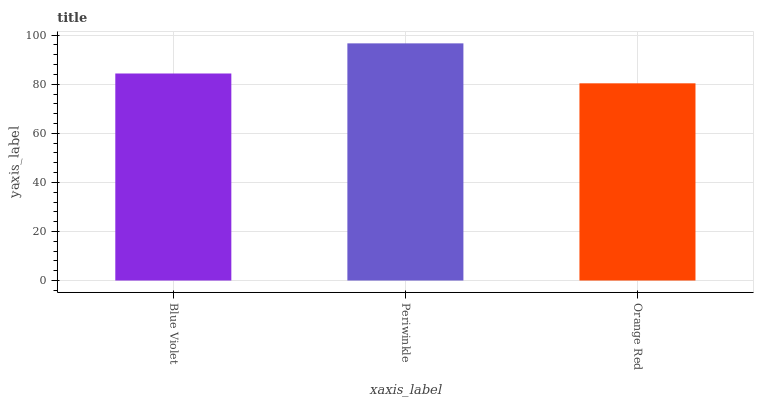Is Orange Red the minimum?
Answer yes or no. Yes. Is Periwinkle the maximum?
Answer yes or no. Yes. Is Periwinkle the minimum?
Answer yes or no. No. Is Orange Red the maximum?
Answer yes or no. No. Is Periwinkle greater than Orange Red?
Answer yes or no. Yes. Is Orange Red less than Periwinkle?
Answer yes or no. Yes. Is Orange Red greater than Periwinkle?
Answer yes or no. No. Is Periwinkle less than Orange Red?
Answer yes or no. No. Is Blue Violet the high median?
Answer yes or no. Yes. Is Blue Violet the low median?
Answer yes or no. Yes. Is Periwinkle the high median?
Answer yes or no. No. Is Periwinkle the low median?
Answer yes or no. No. 